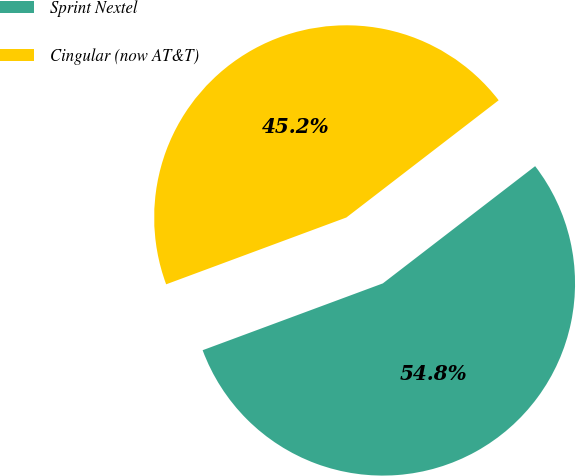Convert chart. <chart><loc_0><loc_0><loc_500><loc_500><pie_chart><fcel>Sprint Nextel<fcel>Cingular (now AT&T)<nl><fcel>54.79%<fcel>45.21%<nl></chart> 